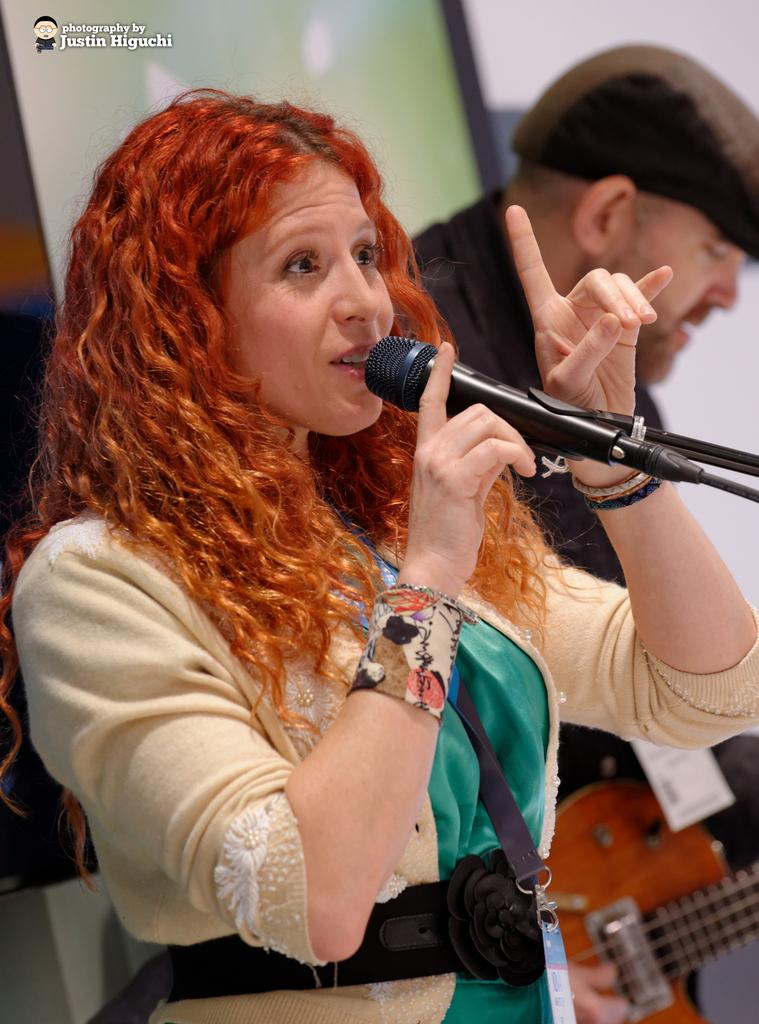What is the woman holding in the image? The woman is holding a microphone. What is the woman doing with the microphone? The woman is talking. What is the woman wearing in the image? The woman is wearing a jacket. What is the person next to the woman doing? The person is playing a guitar. What can be seen on the person's head? The person is wearing a cap. How many goldfish are swimming in the background of the image? There are no goldfish present in the image. The image features a woman holding a microphone and talking, as well as a person playing a guitar and wearing a cap. There is no mention of goldfish or any aquatic elements in the image. 